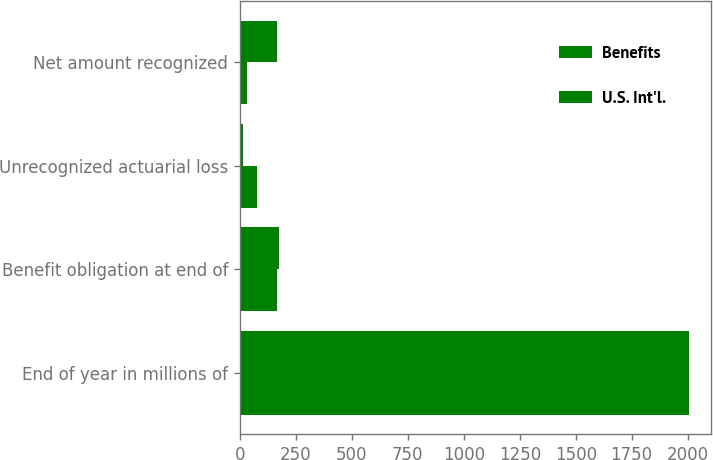<chart> <loc_0><loc_0><loc_500><loc_500><stacked_bar_chart><ecel><fcel>End of year in millions of<fcel>Benefit obligation at end of<fcel>Unrecognized actuarial loss<fcel>Net amount recognized<nl><fcel>Benefits<fcel>2004<fcel>166<fcel>74<fcel>32<nl><fcel>U.S. Int'l.<fcel>2004<fcel>175<fcel>12<fcel>166<nl></chart> 